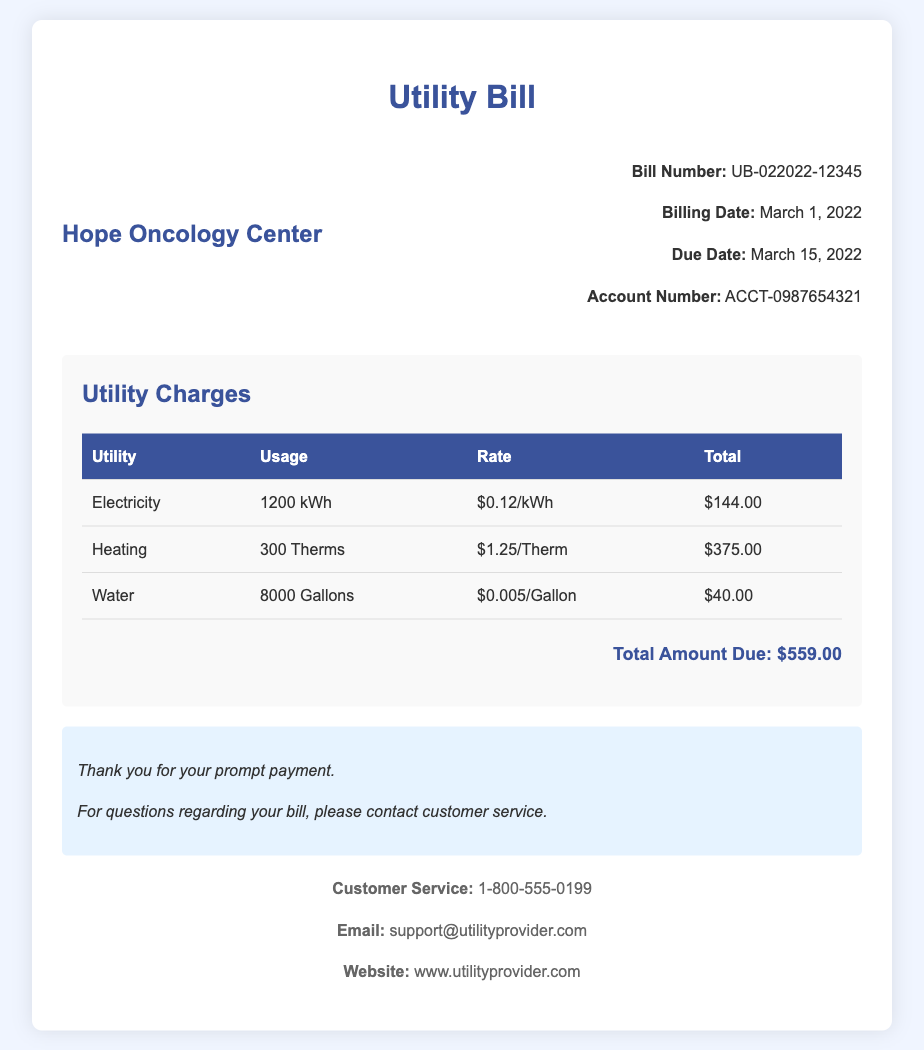What is the bill number? The bill number is listed in the bill information section, which indicates UB-022022-12345.
Answer: UB-022022-12345 What is the billing date? The billing date is found in the bill information, showing March 1, 2022.
Answer: March 1, 2022 How much was charged for heating? The charges section shows the total for heating as $375.00.
Answer: $375.00 What is the total amount due? The total amount due is clearly stated at the bottom of the charges section as $559.00.
Answer: $559.00 What is the rate per gallon of water? The rate per gallon of water is provided in the charges table, which is $0.005/Gallon.
Answer: $0.005/Gallon What is the usage for electricity? The usage for electricity is included in the table under the electricity utility, which is 1200 kWh.
Answer: 1200 kWh What is the due date for the bill? The due date is mentioned in the bill information, indicated as March 15, 2022.
Answer: March 15, 2022 What is the customer's service contact number? The customer service contact number is listed in the contact section as 1-800-555-0199.
Answer: 1-800-555-0199 What utility shows the least total charge? Comparing all utility charges, the total for water is the least at $40.00.
Answer: $40.00 